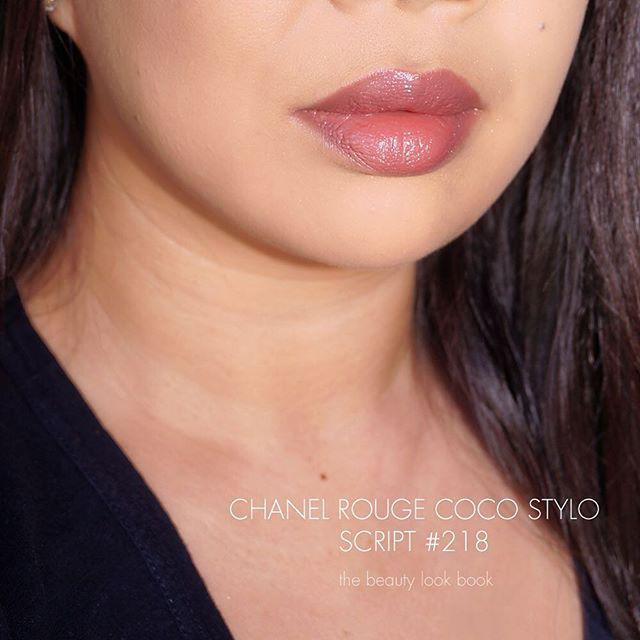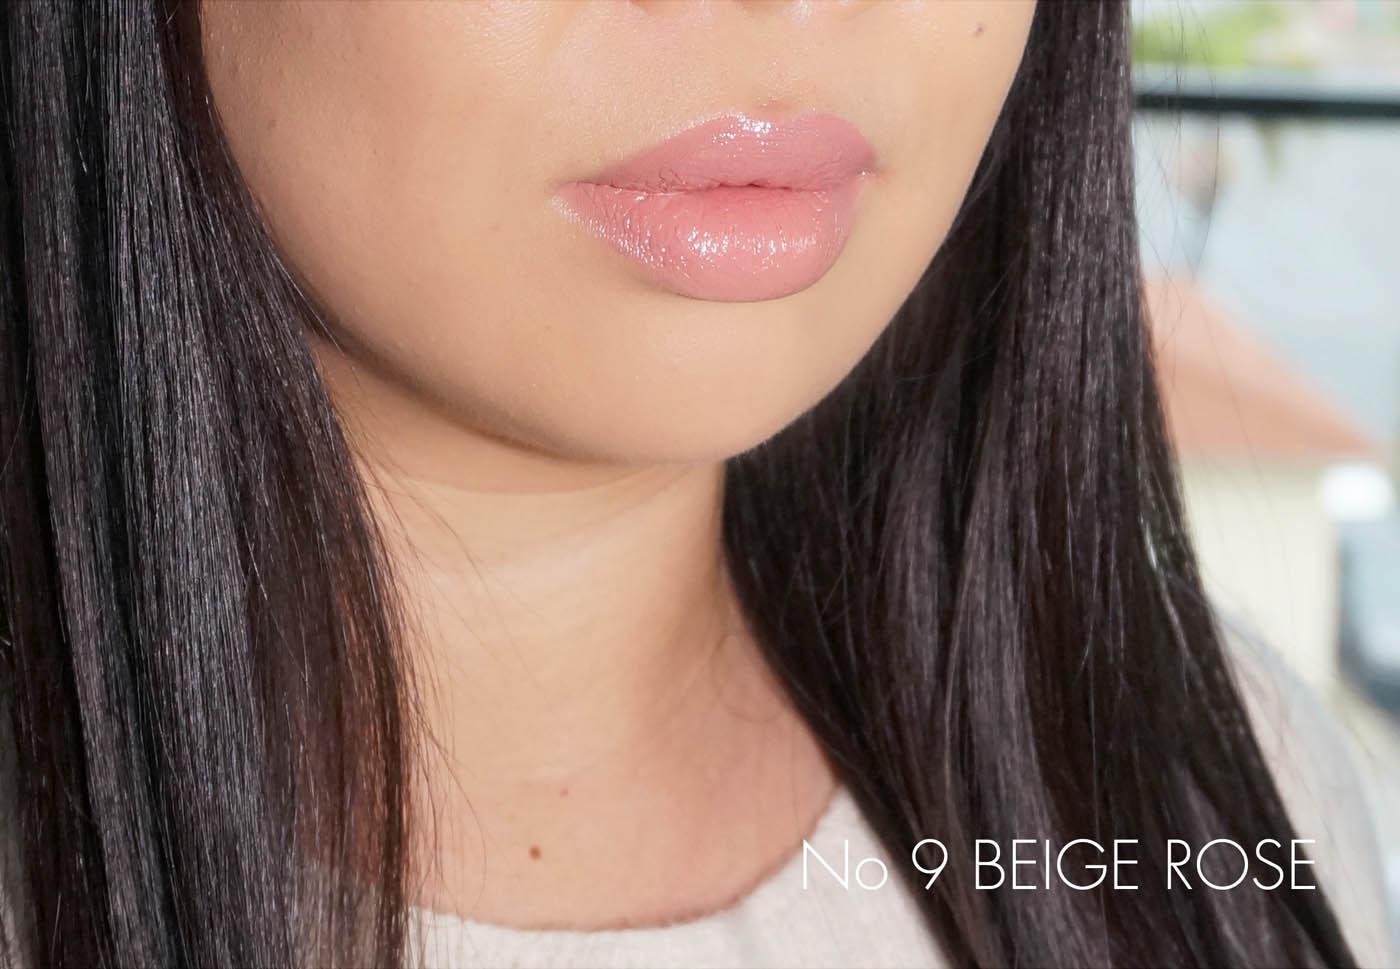The first image is the image on the left, the second image is the image on the right. Considering the images on both sides, is "Both images show a brunette model with tinted, closed lips, and both models wear a pale top with a round neckline." valid? Answer yes or no. No. The first image is the image on the left, the second image is the image on the right. Analyze the images presented: Is the assertion "There are two girls wearing pale pink lipstick." valid? Answer yes or no. Yes. 